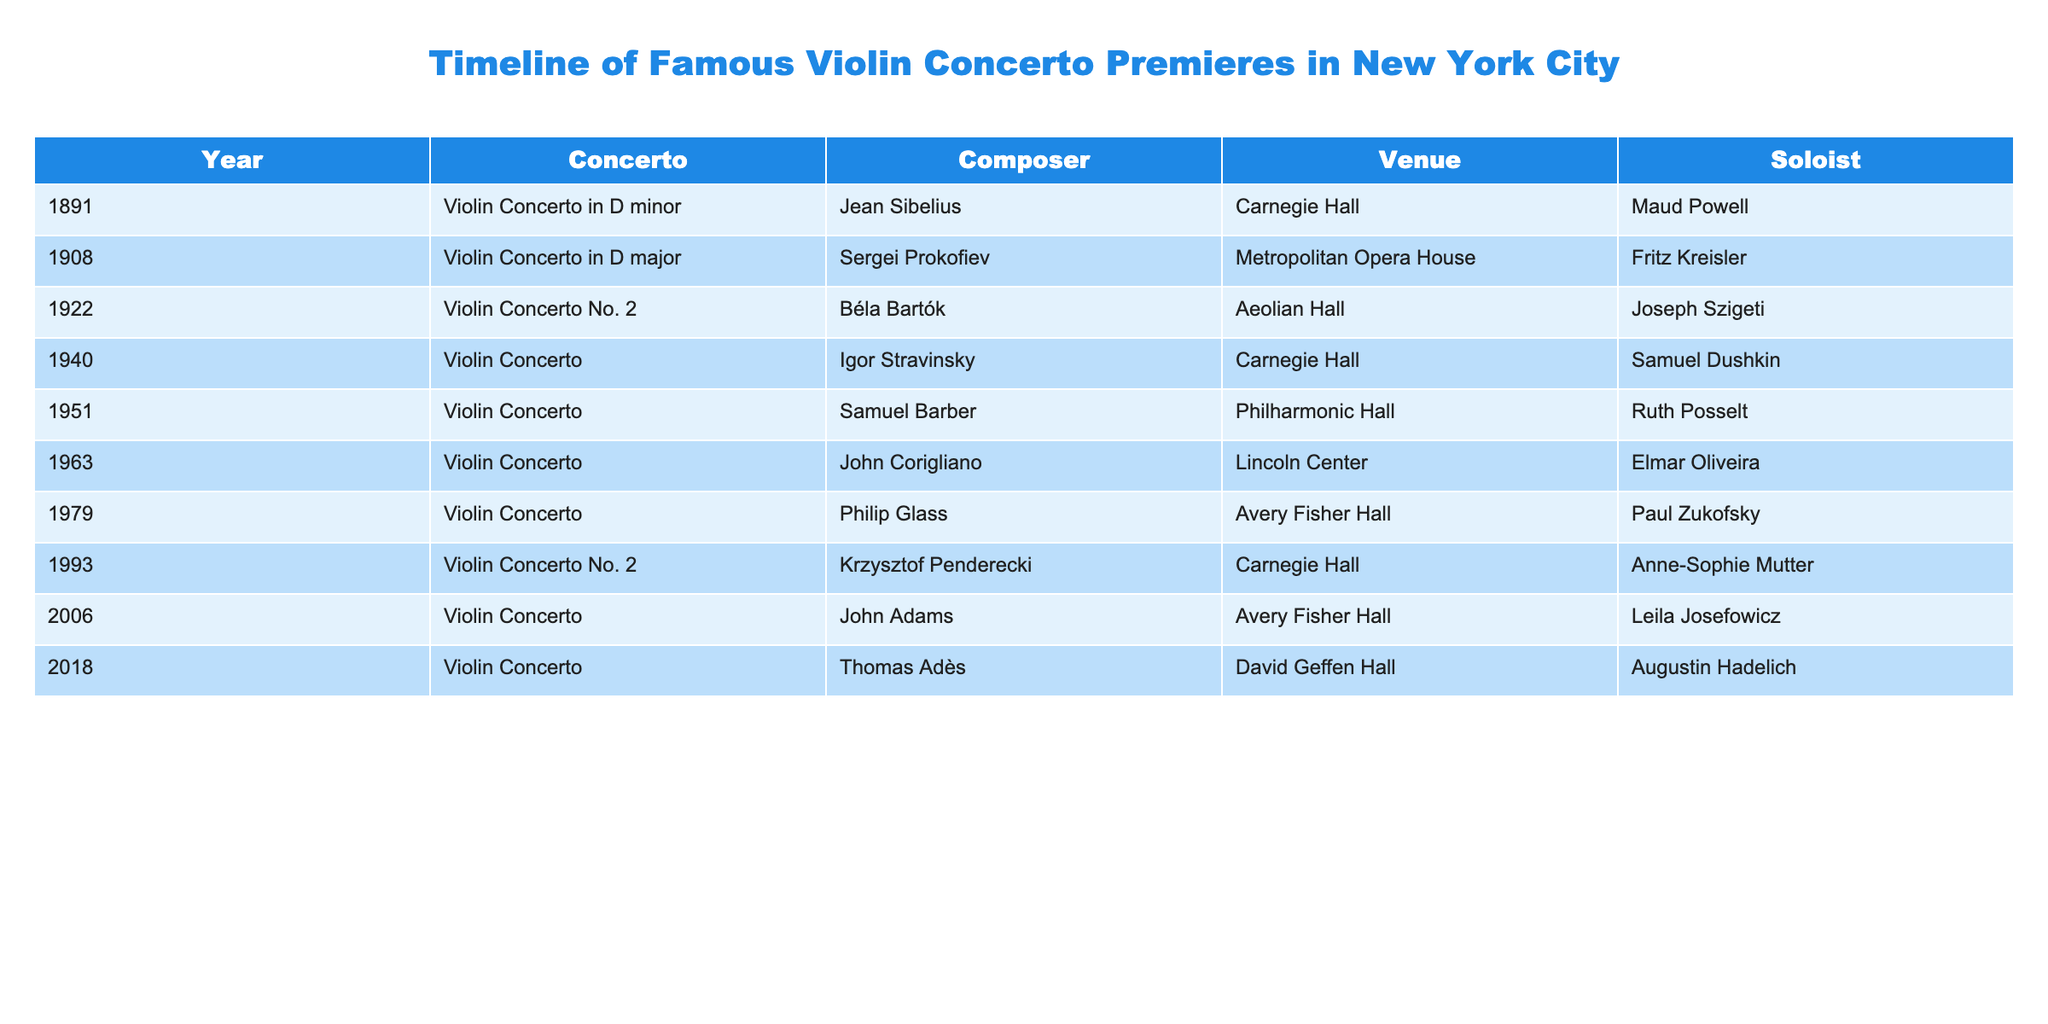What year was the Violin Concerto by Samuel Barber premiered? The table lists the premieres of various violin concertos along with their composers and venues. Locating the row for Samuel Barber shows that his Violin Concerto premiered in the year 1951.
Answer: 1951 Which composer had a violin concerto premiered in 1993? Searching through the table, I can find the entry for the year 1993, where the concerto by Krzysztof Penderecki is mentioned. Thus, he is the composer who had a violin concerto premiered that year.
Answer: Krzysztof Penderecki How many violin concertos were premiered at Carnegie Hall? By reviewing the venue column in the table, I count three entries where Carnegie Hall is listed: the concertos by Jean Sibelius (1891), Igor Stravinsky (1940), and Krzysztof Penderecki (1993). Therefore, the total is three.
Answer: 3 Did any violin concertos premiere in the 2000s? Looking at the table, I see there are two violin concertos with premiere years listed after 2000, specifically in 2006 and 2018 (composers John Adams and Thomas Adès, respectively). Therefore, the answer is yes.
Answer: Yes Which soloist performed the earliest violin concerto listed in the table? The first row of the table lists the year 1891. The soloist for the violin concerto by Jean Sibelius that premiered that year is Maud Powell, making her the earliest soloist.
Answer: Maud Powell Was Elmar Oliveira the soloist for more than one concerto in this table? Referring to the table, Elmar Oliveira is mentioned as the soloist only once for John Corigliano's concerto in 1963. Thus, he did not perform more than one concerto in this list.
Answer: No Which concerto had the last premiere according to the table? The last entry in the table shows the year 2018, which pertains to the Violin Concerto by Thomas Adès, indicating that it was the most recent premiere listed.
Answer: Violin Concerto by Thomas Adès What is the average number of years between the premieres of the concertos listed? The concertos span from 1891 to 2018, which is a total of 127 years. There are 9 concertos, so to find the average interval, I subtract the first year from the last year (2018 - 1891 = 127) and divide by the number of intervals, which is 8 (9 concerts lead to 8 intervals). Thus, the average is 127/8 = 15.875.
Answer: Approximately 15.88 years 